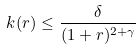Convert formula to latex. <formula><loc_0><loc_0><loc_500><loc_500>\ k ( r ) \leq \frac { \delta } { ( 1 + r ) ^ { 2 + \gamma } }</formula> 